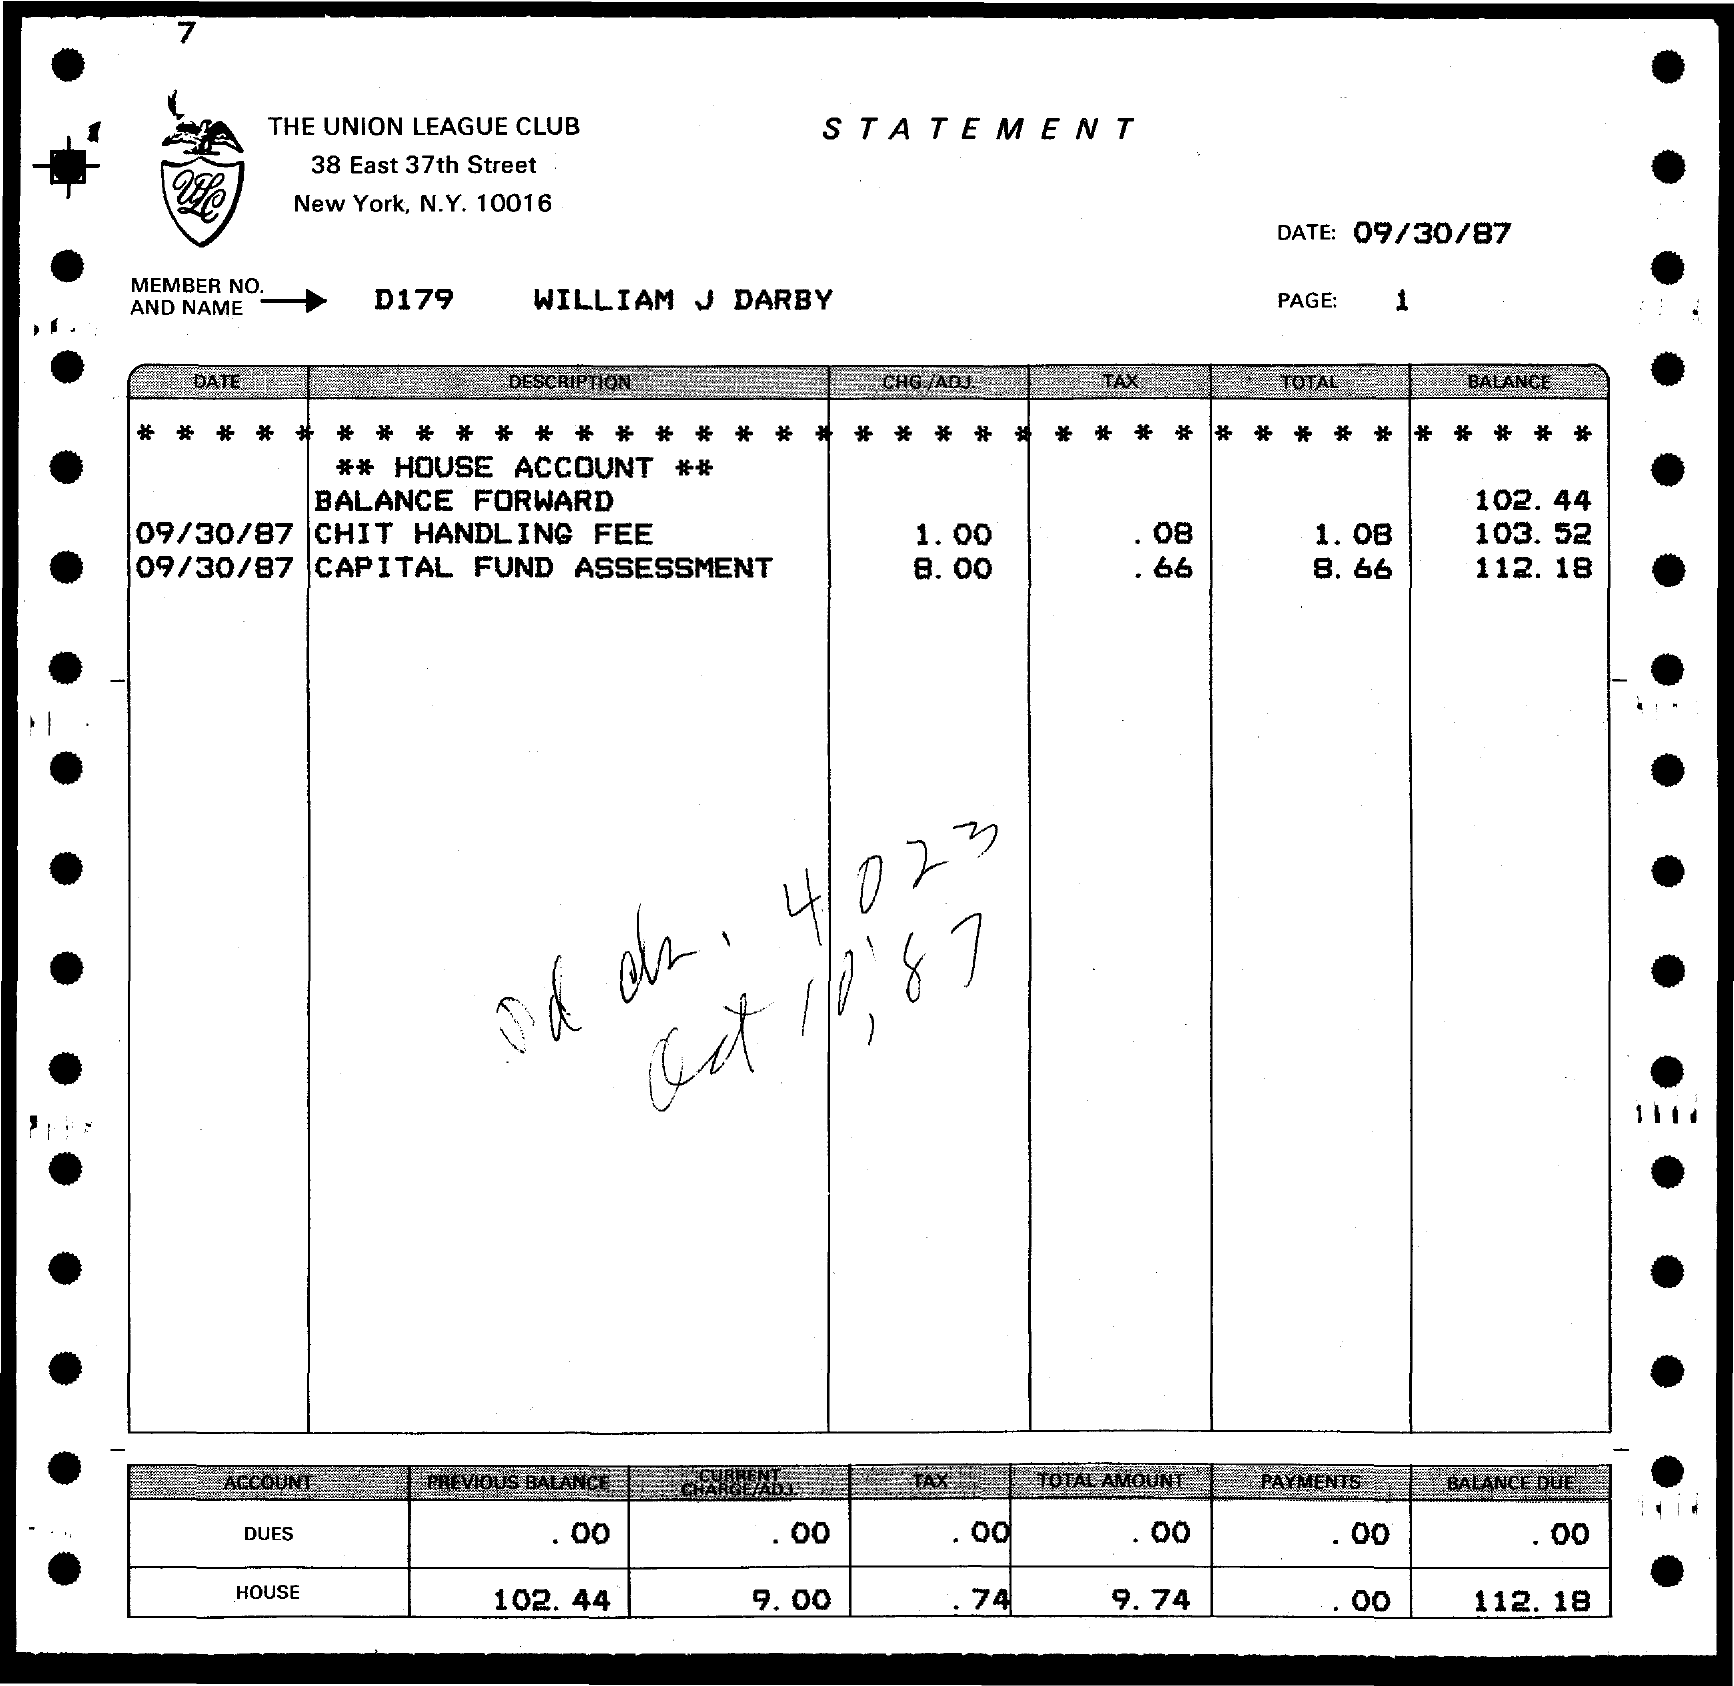Point out several critical features in this image. The member number and name are D179, which is William J Darby. The letterhead mentions "The Union League Club. The house balance due is $112.18. 